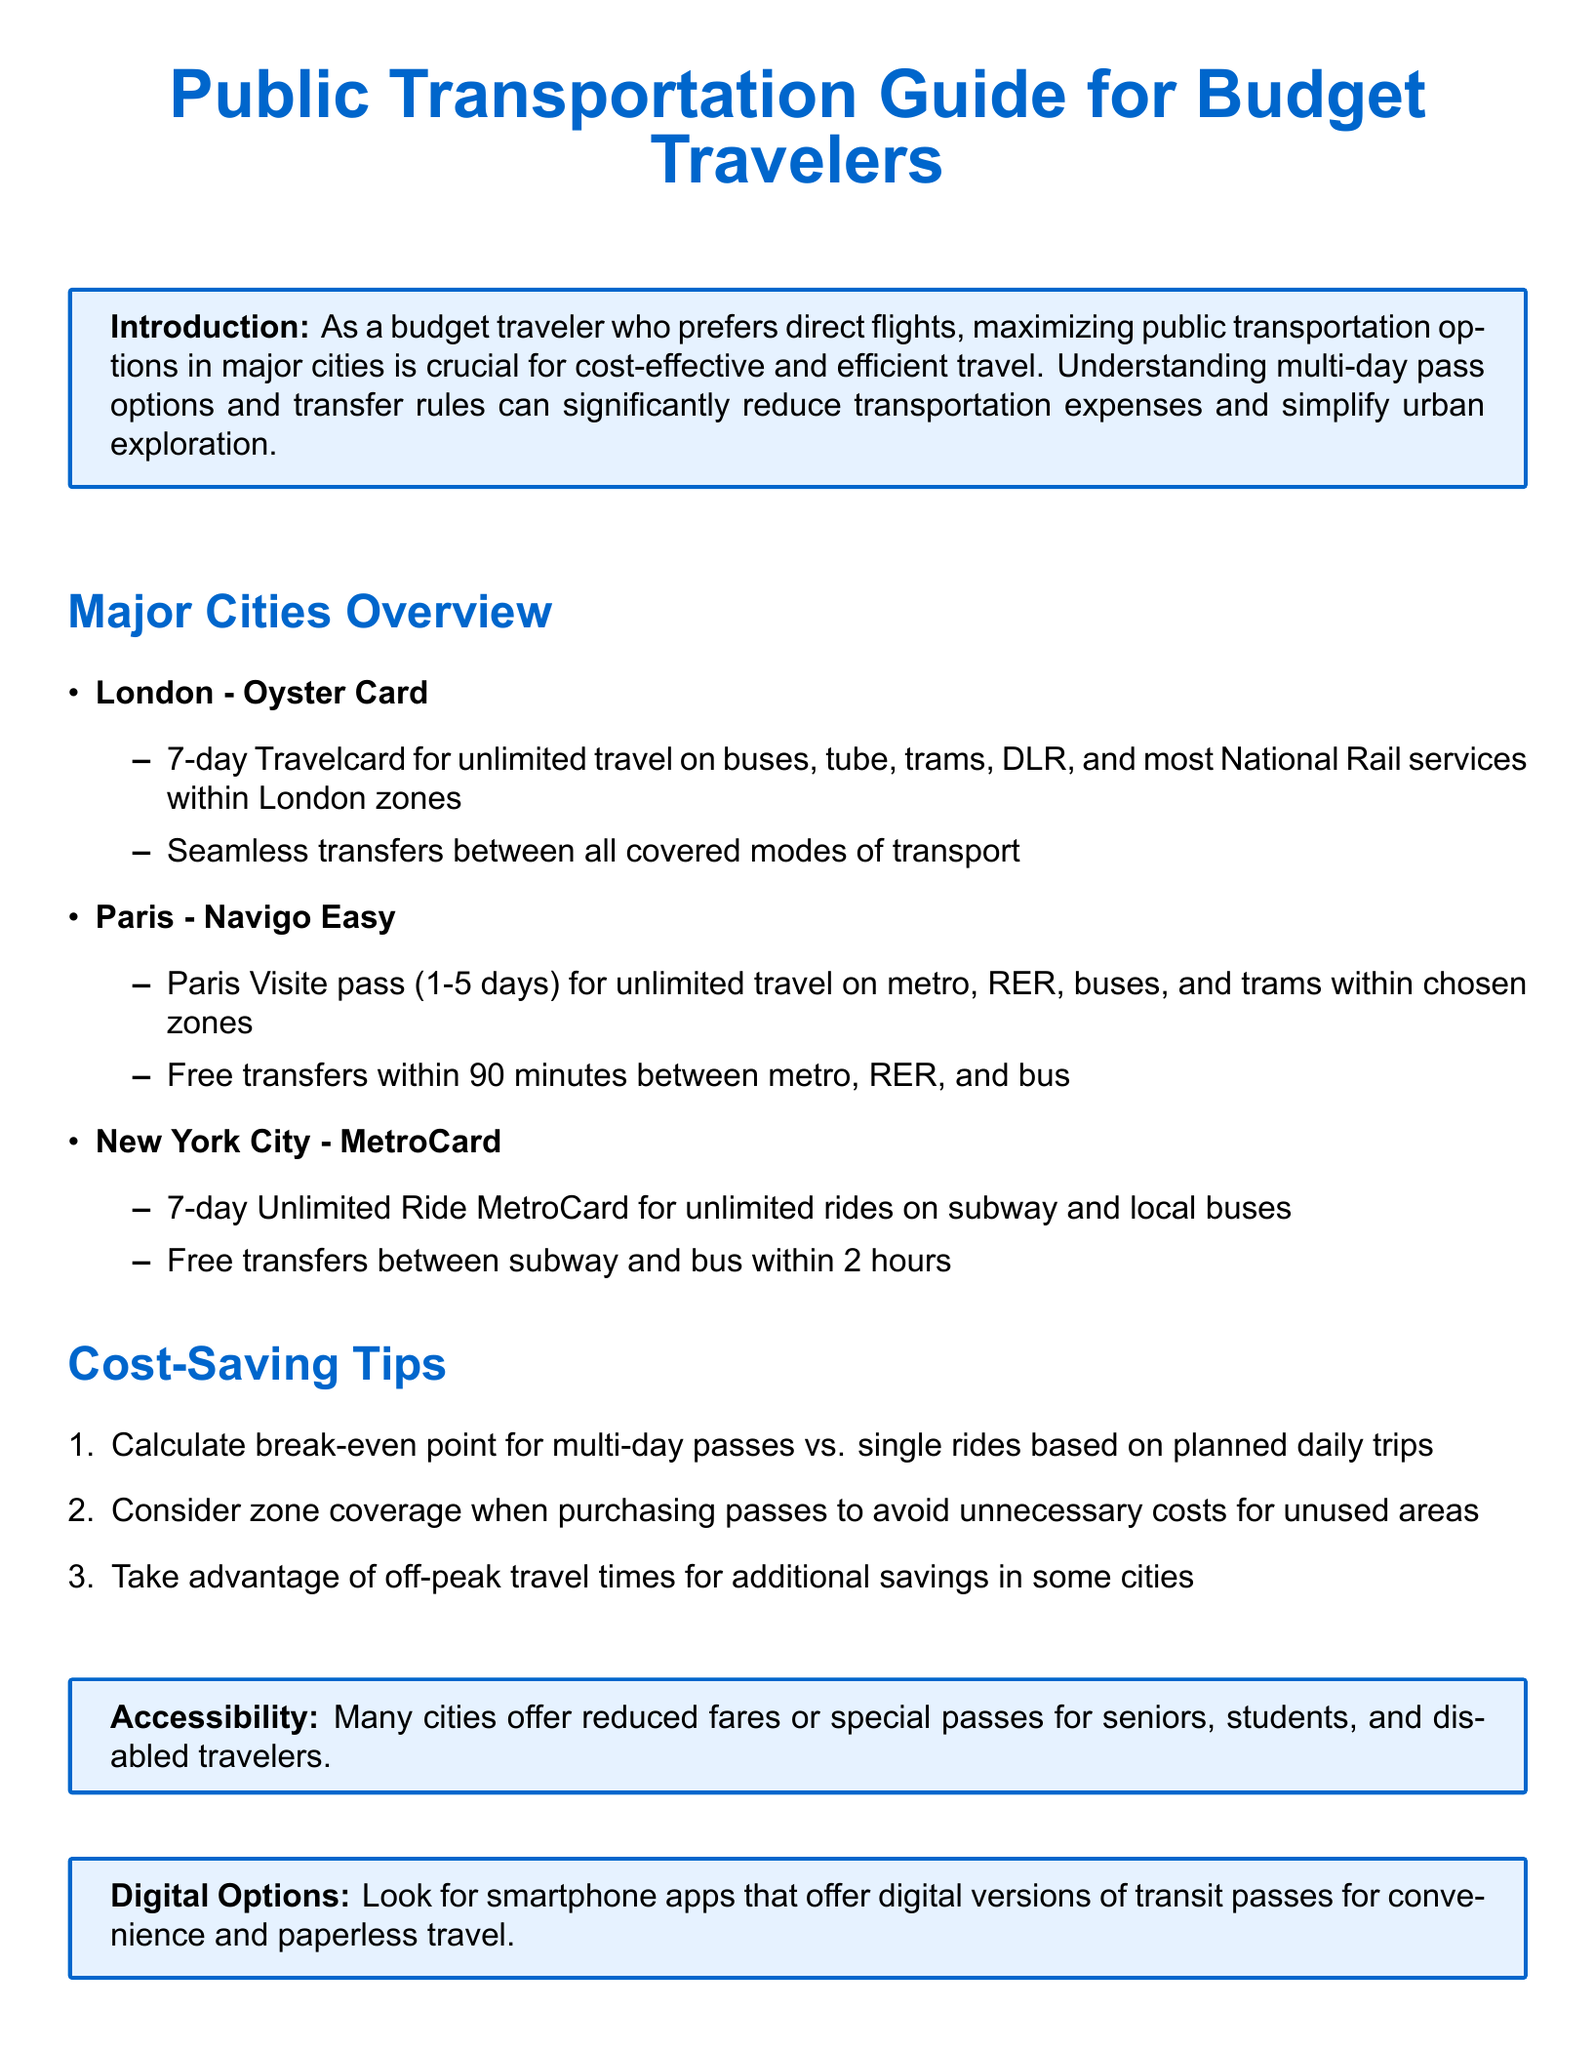What is the main transportation option in London? The document specifies the Oyster Card as the main transportation option in London.
Answer: Oyster Card How long is the validity of the Paris Visite pass? The validity of the Paris Visite pass ranges from 1 to 5 days according to the document.
Answer: 1-5 days What is the transfer time rule for New York City's MetroCard? The document states that transfers are free between subway and bus within 2 hours.
Answer: 2 hours What discount options are available for special groups? The document mentions reduced fares or special passes for seniors, students, and disabled travelers.
Answer: Reduced fares What should travelers consider to avoid unnecessary costs? According to the document, travelers should consider zone coverage when purchasing passes.
Answer: Zone coverage What is a recommended tip for calculating pass value? The document suggests calculating the break-even point for multi-day passes vs. single rides.
Answer: Break-even point Which city's pass allows transfers within 90 minutes? The Paris Visite pass allows free transfers within 90 minutes as mentioned in the document.
Answer: 90 minutes How many days does the 7-day Unlimited Ride MetroCard last? The document specifies that the 7-day Unlimited Ride MetroCard lasts for 7 days.
Answer: 7 days What is one advantage of digital options mentioned in the document? The document notes convenience and paperless travel as advantages of digital options.
Answer: Convenience 